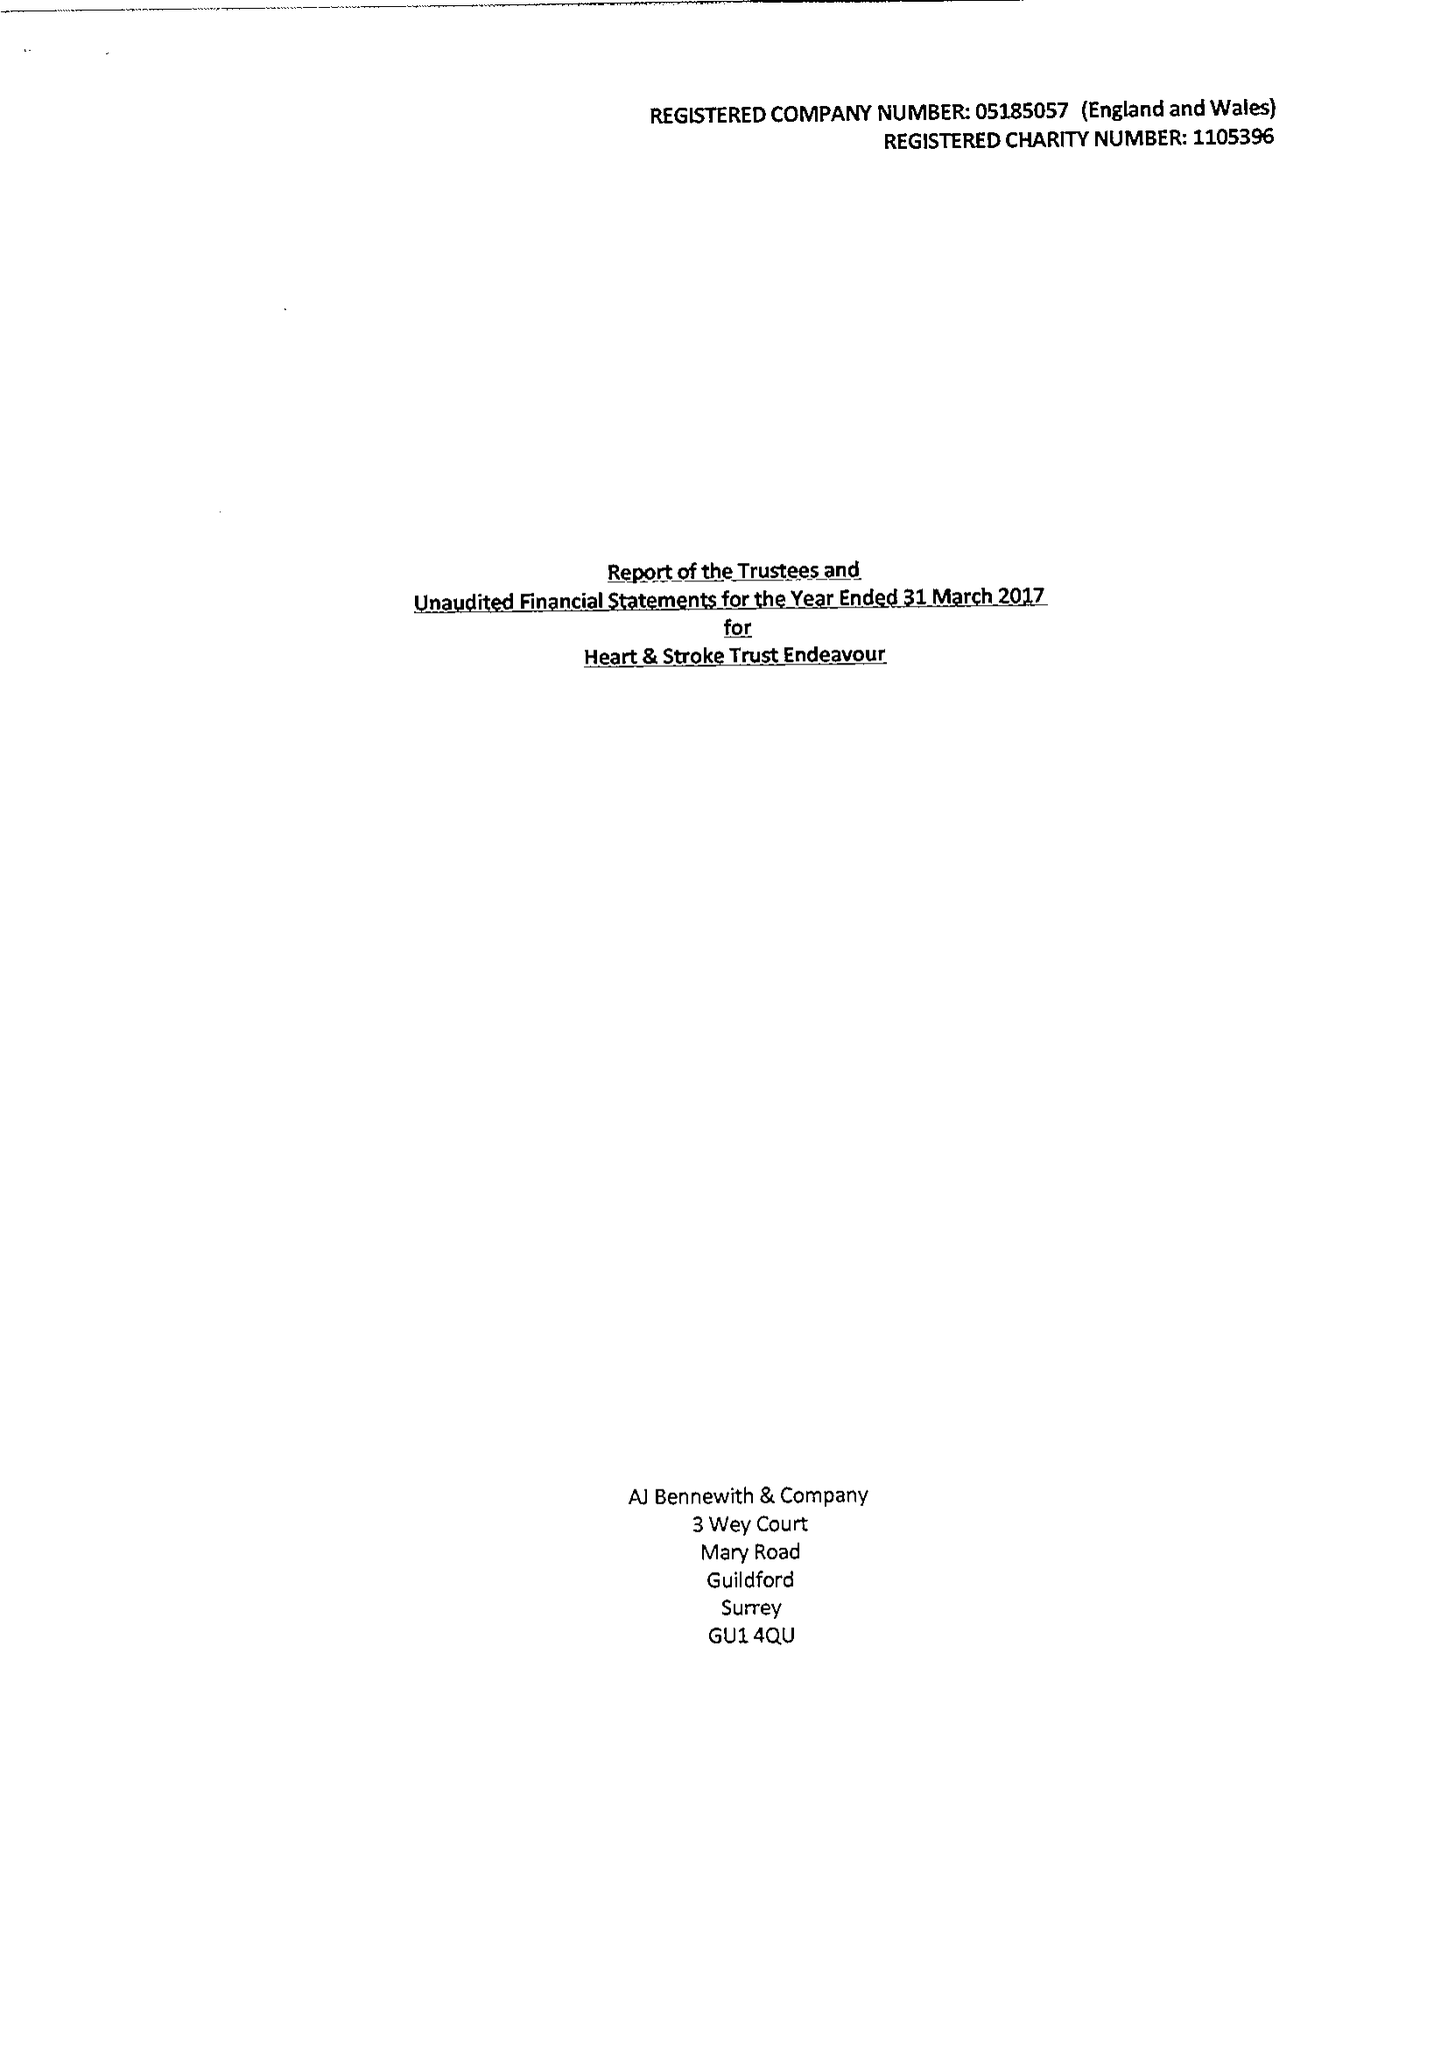What is the value for the charity_number?
Answer the question using a single word or phrase. 1105396 